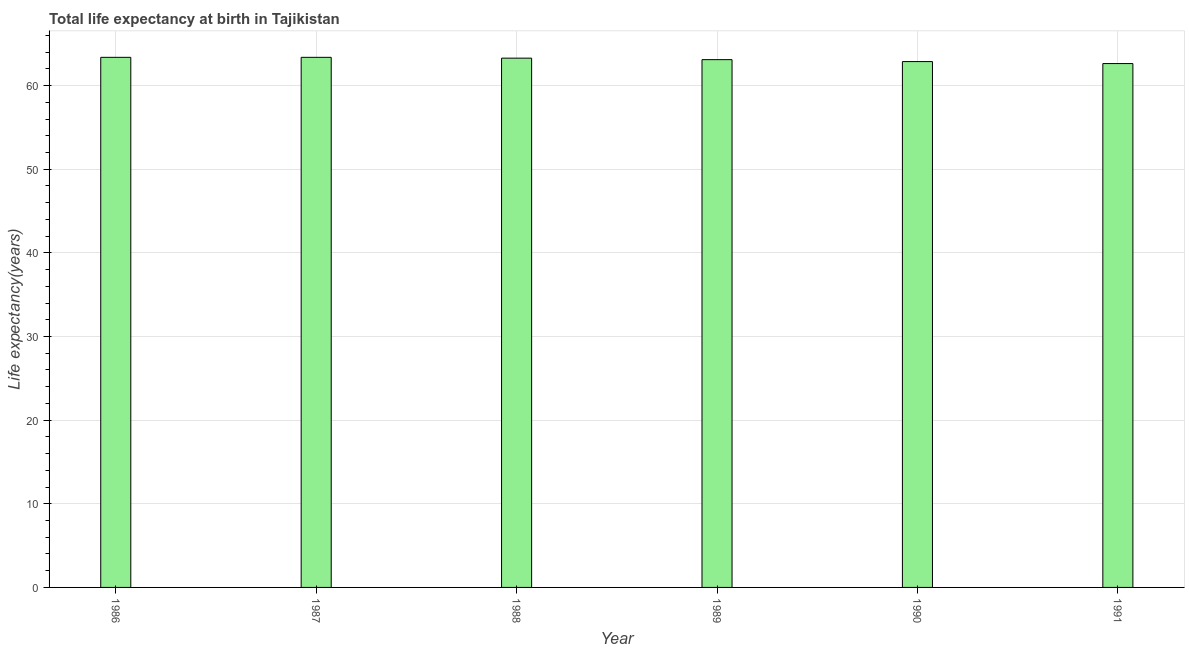Does the graph contain any zero values?
Provide a short and direct response. No. What is the title of the graph?
Offer a terse response. Total life expectancy at birth in Tajikistan. What is the label or title of the X-axis?
Make the answer very short. Year. What is the label or title of the Y-axis?
Your answer should be very brief. Life expectancy(years). What is the life expectancy at birth in 1987?
Offer a very short reply. 63.37. Across all years, what is the maximum life expectancy at birth?
Ensure brevity in your answer.  63.37. Across all years, what is the minimum life expectancy at birth?
Your answer should be compact. 62.63. In which year was the life expectancy at birth maximum?
Offer a terse response. 1986. What is the sum of the life expectancy at birth?
Make the answer very short. 378.61. What is the difference between the life expectancy at birth in 1987 and 1991?
Your answer should be compact. 0.75. What is the average life expectancy at birth per year?
Make the answer very short. 63.1. What is the median life expectancy at birth?
Your response must be concise. 63.19. Is the difference between the life expectancy at birth in 1989 and 1991 greater than the difference between any two years?
Make the answer very short. No. What is the difference between the highest and the second highest life expectancy at birth?
Provide a short and direct response. 0. Is the sum of the life expectancy at birth in 1986 and 1988 greater than the maximum life expectancy at birth across all years?
Provide a succinct answer. Yes. What is the difference between the highest and the lowest life expectancy at birth?
Your answer should be compact. 0.75. How many years are there in the graph?
Give a very brief answer. 6. Are the values on the major ticks of Y-axis written in scientific E-notation?
Keep it short and to the point. No. What is the Life expectancy(years) in 1986?
Your answer should be very brief. 63.37. What is the Life expectancy(years) in 1987?
Provide a succinct answer. 63.37. What is the Life expectancy(years) of 1988?
Offer a terse response. 63.28. What is the Life expectancy(years) in 1989?
Keep it short and to the point. 63.1. What is the Life expectancy(years) in 1990?
Your answer should be compact. 62.86. What is the Life expectancy(years) in 1991?
Your answer should be compact. 62.63. What is the difference between the Life expectancy(years) in 1986 and 1988?
Make the answer very short. 0.1. What is the difference between the Life expectancy(years) in 1986 and 1989?
Ensure brevity in your answer.  0.28. What is the difference between the Life expectancy(years) in 1986 and 1990?
Your answer should be very brief. 0.51. What is the difference between the Life expectancy(years) in 1986 and 1991?
Your answer should be compact. 0.75. What is the difference between the Life expectancy(years) in 1987 and 1988?
Make the answer very short. 0.1. What is the difference between the Life expectancy(years) in 1987 and 1989?
Offer a terse response. 0.28. What is the difference between the Life expectancy(years) in 1987 and 1990?
Offer a very short reply. 0.51. What is the difference between the Life expectancy(years) in 1987 and 1991?
Make the answer very short. 0.75. What is the difference between the Life expectancy(years) in 1988 and 1989?
Offer a very short reply. 0.18. What is the difference between the Life expectancy(years) in 1988 and 1990?
Your answer should be compact. 0.41. What is the difference between the Life expectancy(years) in 1988 and 1991?
Your response must be concise. 0.65. What is the difference between the Life expectancy(years) in 1989 and 1990?
Your answer should be very brief. 0.23. What is the difference between the Life expectancy(years) in 1989 and 1991?
Offer a very short reply. 0.47. What is the difference between the Life expectancy(years) in 1990 and 1991?
Keep it short and to the point. 0.24. What is the ratio of the Life expectancy(years) in 1986 to that in 1987?
Provide a short and direct response. 1. What is the ratio of the Life expectancy(years) in 1986 to that in 1990?
Your response must be concise. 1.01. What is the ratio of the Life expectancy(years) in 1987 to that in 1988?
Offer a terse response. 1. What is the ratio of the Life expectancy(years) in 1987 to that in 1990?
Provide a succinct answer. 1.01. What is the ratio of the Life expectancy(years) in 1988 to that in 1991?
Your answer should be compact. 1.01. What is the ratio of the Life expectancy(years) in 1989 to that in 1990?
Ensure brevity in your answer.  1. What is the ratio of the Life expectancy(years) in 1990 to that in 1991?
Offer a very short reply. 1. 